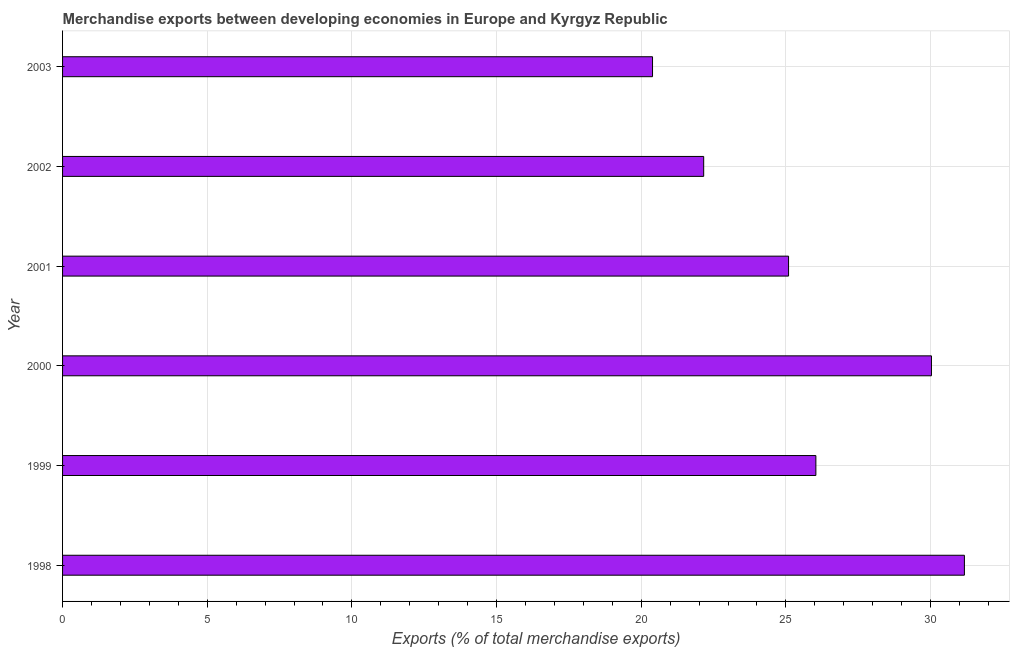Does the graph contain grids?
Provide a succinct answer. Yes. What is the title of the graph?
Make the answer very short. Merchandise exports between developing economies in Europe and Kyrgyz Republic. What is the label or title of the X-axis?
Your response must be concise. Exports (% of total merchandise exports). What is the label or title of the Y-axis?
Keep it short and to the point. Year. What is the merchandise exports in 1999?
Keep it short and to the point. 26.04. Across all years, what is the maximum merchandise exports?
Provide a succinct answer. 31.17. Across all years, what is the minimum merchandise exports?
Your answer should be very brief. 20.39. In which year was the merchandise exports maximum?
Your answer should be very brief. 1998. In which year was the merchandise exports minimum?
Keep it short and to the point. 2003. What is the sum of the merchandise exports?
Your answer should be very brief. 154.87. What is the difference between the merchandise exports in 2000 and 2001?
Provide a short and direct response. 4.94. What is the average merchandise exports per year?
Ensure brevity in your answer.  25.81. What is the median merchandise exports?
Your answer should be very brief. 25.56. In how many years, is the merchandise exports greater than 4 %?
Give a very brief answer. 6. Do a majority of the years between 1999 and 2003 (inclusive) have merchandise exports greater than 9 %?
Your answer should be compact. Yes. What is the ratio of the merchandise exports in 1998 to that in 2000?
Offer a very short reply. 1.04. What is the difference between the highest and the second highest merchandise exports?
Give a very brief answer. 1.14. Is the sum of the merchandise exports in 1999 and 2000 greater than the maximum merchandise exports across all years?
Make the answer very short. Yes. What is the difference between the highest and the lowest merchandise exports?
Your answer should be very brief. 10.78. How many bars are there?
Your answer should be compact. 6. Are all the bars in the graph horizontal?
Your response must be concise. Yes. What is the Exports (% of total merchandise exports) in 1998?
Offer a terse response. 31.17. What is the Exports (% of total merchandise exports) of 1999?
Keep it short and to the point. 26.04. What is the Exports (% of total merchandise exports) of 2000?
Offer a terse response. 30.03. What is the Exports (% of total merchandise exports) of 2001?
Keep it short and to the point. 25.09. What is the Exports (% of total merchandise exports) of 2002?
Your answer should be very brief. 22.16. What is the Exports (% of total merchandise exports) in 2003?
Your answer should be very brief. 20.39. What is the difference between the Exports (% of total merchandise exports) in 1998 and 1999?
Make the answer very short. 5.13. What is the difference between the Exports (% of total merchandise exports) in 1998 and 2000?
Provide a short and direct response. 1.14. What is the difference between the Exports (% of total merchandise exports) in 1998 and 2001?
Give a very brief answer. 6.08. What is the difference between the Exports (% of total merchandise exports) in 1998 and 2002?
Your answer should be very brief. 9.01. What is the difference between the Exports (% of total merchandise exports) in 1998 and 2003?
Your answer should be compact. 10.78. What is the difference between the Exports (% of total merchandise exports) in 1999 and 2000?
Keep it short and to the point. -3.99. What is the difference between the Exports (% of total merchandise exports) in 1999 and 2001?
Make the answer very short. 0.94. What is the difference between the Exports (% of total merchandise exports) in 1999 and 2002?
Provide a succinct answer. 3.88. What is the difference between the Exports (% of total merchandise exports) in 1999 and 2003?
Your answer should be compact. 5.65. What is the difference between the Exports (% of total merchandise exports) in 2000 and 2001?
Offer a terse response. 4.94. What is the difference between the Exports (% of total merchandise exports) in 2000 and 2002?
Provide a short and direct response. 7.87. What is the difference between the Exports (% of total merchandise exports) in 2000 and 2003?
Provide a succinct answer. 9.64. What is the difference between the Exports (% of total merchandise exports) in 2001 and 2002?
Keep it short and to the point. 2.93. What is the difference between the Exports (% of total merchandise exports) in 2001 and 2003?
Provide a succinct answer. 4.7. What is the difference between the Exports (% of total merchandise exports) in 2002 and 2003?
Give a very brief answer. 1.77. What is the ratio of the Exports (% of total merchandise exports) in 1998 to that in 1999?
Provide a succinct answer. 1.2. What is the ratio of the Exports (% of total merchandise exports) in 1998 to that in 2000?
Your answer should be compact. 1.04. What is the ratio of the Exports (% of total merchandise exports) in 1998 to that in 2001?
Your answer should be very brief. 1.24. What is the ratio of the Exports (% of total merchandise exports) in 1998 to that in 2002?
Your response must be concise. 1.41. What is the ratio of the Exports (% of total merchandise exports) in 1998 to that in 2003?
Give a very brief answer. 1.53. What is the ratio of the Exports (% of total merchandise exports) in 1999 to that in 2000?
Your answer should be very brief. 0.87. What is the ratio of the Exports (% of total merchandise exports) in 1999 to that in 2001?
Provide a short and direct response. 1.04. What is the ratio of the Exports (% of total merchandise exports) in 1999 to that in 2002?
Give a very brief answer. 1.18. What is the ratio of the Exports (% of total merchandise exports) in 1999 to that in 2003?
Your response must be concise. 1.28. What is the ratio of the Exports (% of total merchandise exports) in 2000 to that in 2001?
Give a very brief answer. 1.2. What is the ratio of the Exports (% of total merchandise exports) in 2000 to that in 2002?
Your answer should be compact. 1.35. What is the ratio of the Exports (% of total merchandise exports) in 2000 to that in 2003?
Offer a terse response. 1.47. What is the ratio of the Exports (% of total merchandise exports) in 2001 to that in 2002?
Give a very brief answer. 1.13. What is the ratio of the Exports (% of total merchandise exports) in 2001 to that in 2003?
Make the answer very short. 1.23. What is the ratio of the Exports (% of total merchandise exports) in 2002 to that in 2003?
Provide a succinct answer. 1.09. 